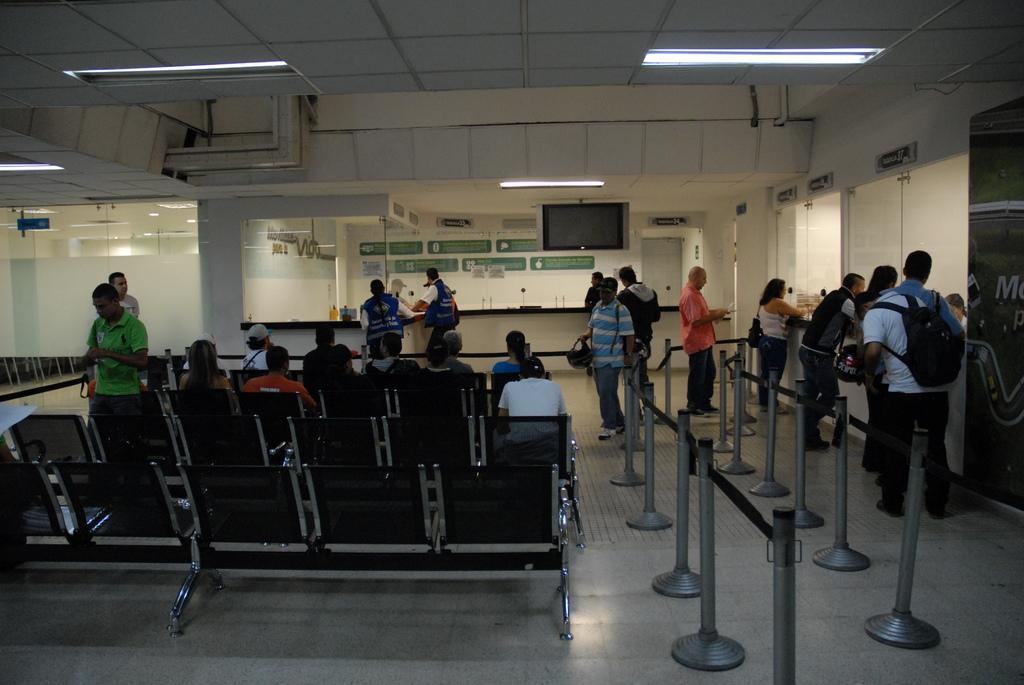Describe this image in one or two sentences. In this image we can see a group of people are standing on the floor, there are group of people sitting on the chairs, there is a fence, there is a counter, there is a television, there are lights, there is a table, there is a glass door, there is a wall and boards on it. 